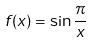<formula> <loc_0><loc_0><loc_500><loc_500>f ( x ) = \sin \frac { \pi } { x }</formula> 